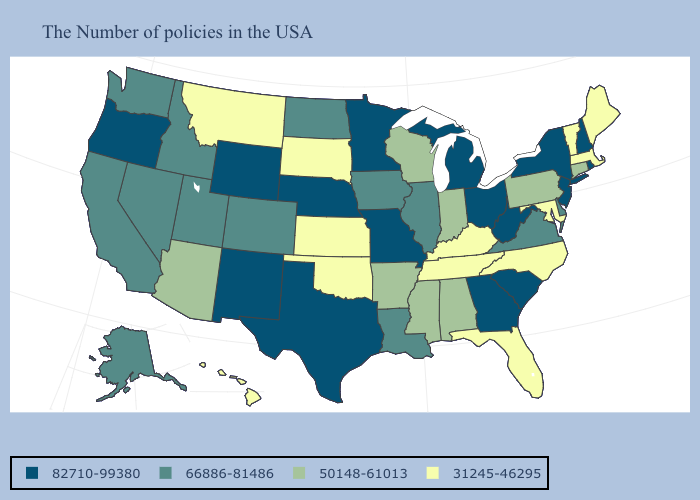What is the value of Wyoming?
Concise answer only. 82710-99380. What is the value of Washington?
Answer briefly. 66886-81486. Among the states that border Wyoming , does Idaho have the highest value?
Quick response, please. No. What is the value of Pennsylvania?
Give a very brief answer. 50148-61013. What is the highest value in the MidWest ?
Write a very short answer. 82710-99380. Is the legend a continuous bar?
Quick response, please. No. Which states hav the highest value in the Northeast?
Short answer required. Rhode Island, New Hampshire, New York, New Jersey. Name the states that have a value in the range 66886-81486?
Quick response, please. Delaware, Virginia, Illinois, Louisiana, Iowa, North Dakota, Colorado, Utah, Idaho, Nevada, California, Washington, Alaska. Among the states that border Iowa , which have the highest value?
Be succinct. Missouri, Minnesota, Nebraska. Name the states that have a value in the range 82710-99380?
Keep it brief. Rhode Island, New Hampshire, New York, New Jersey, South Carolina, West Virginia, Ohio, Georgia, Michigan, Missouri, Minnesota, Nebraska, Texas, Wyoming, New Mexico, Oregon. Name the states that have a value in the range 31245-46295?
Quick response, please. Maine, Massachusetts, Vermont, Maryland, North Carolina, Florida, Kentucky, Tennessee, Kansas, Oklahoma, South Dakota, Montana, Hawaii. Name the states that have a value in the range 66886-81486?
Give a very brief answer. Delaware, Virginia, Illinois, Louisiana, Iowa, North Dakota, Colorado, Utah, Idaho, Nevada, California, Washington, Alaska. Which states have the lowest value in the USA?
Quick response, please. Maine, Massachusetts, Vermont, Maryland, North Carolina, Florida, Kentucky, Tennessee, Kansas, Oklahoma, South Dakota, Montana, Hawaii. Among the states that border Tennessee , which have the highest value?
Give a very brief answer. Georgia, Missouri. What is the lowest value in the USA?
Quick response, please. 31245-46295. 